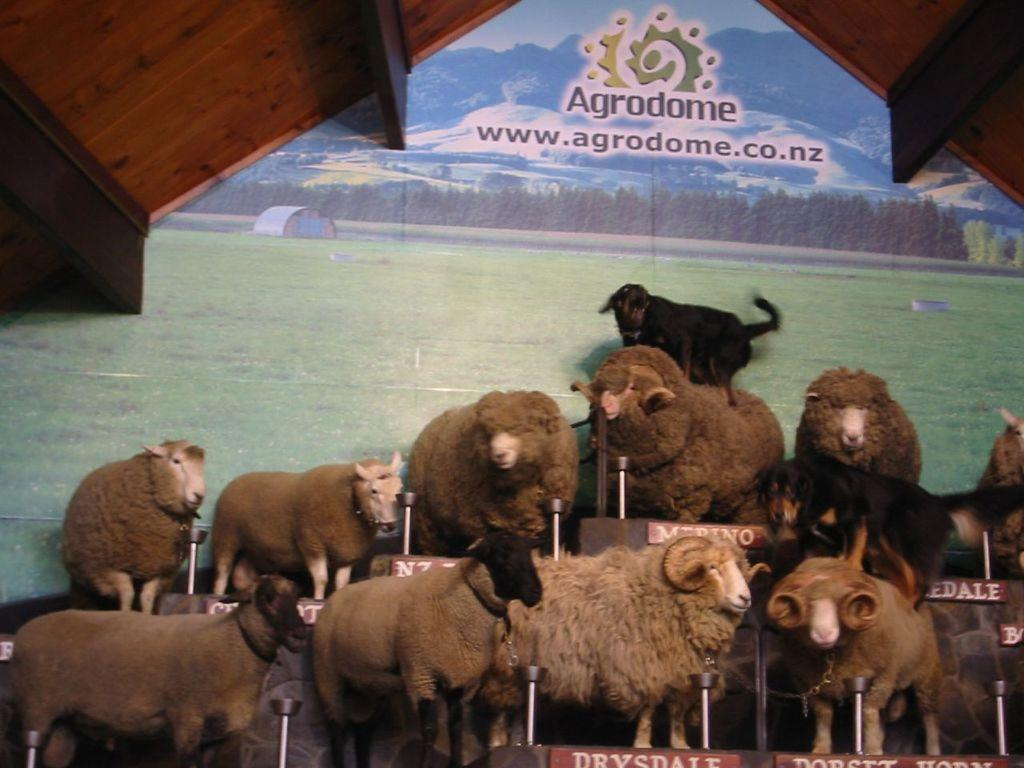What is present in the image that is not human? There are animals standing in the image. What type of information can be found on the boards in the image? There are boards with text in the image. What colors are the objects on the top of the image? The objects on the top of the image are black and brown in color. How many girls are playing with the sack in the image? There are no girls or sacks present in the image. What type of land can be seen in the background of the image? There is no land visible in the image; it only shows animals, boards with text, and objects on the top. 